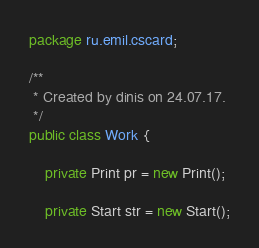<code> <loc_0><loc_0><loc_500><loc_500><_Java_>package ru.emil.cscard;

/**
 * Created by dinis on 24.07.17.
 */
public class Work {

    private Print pr = new Print();

    private Start str = new Start();
</code> 